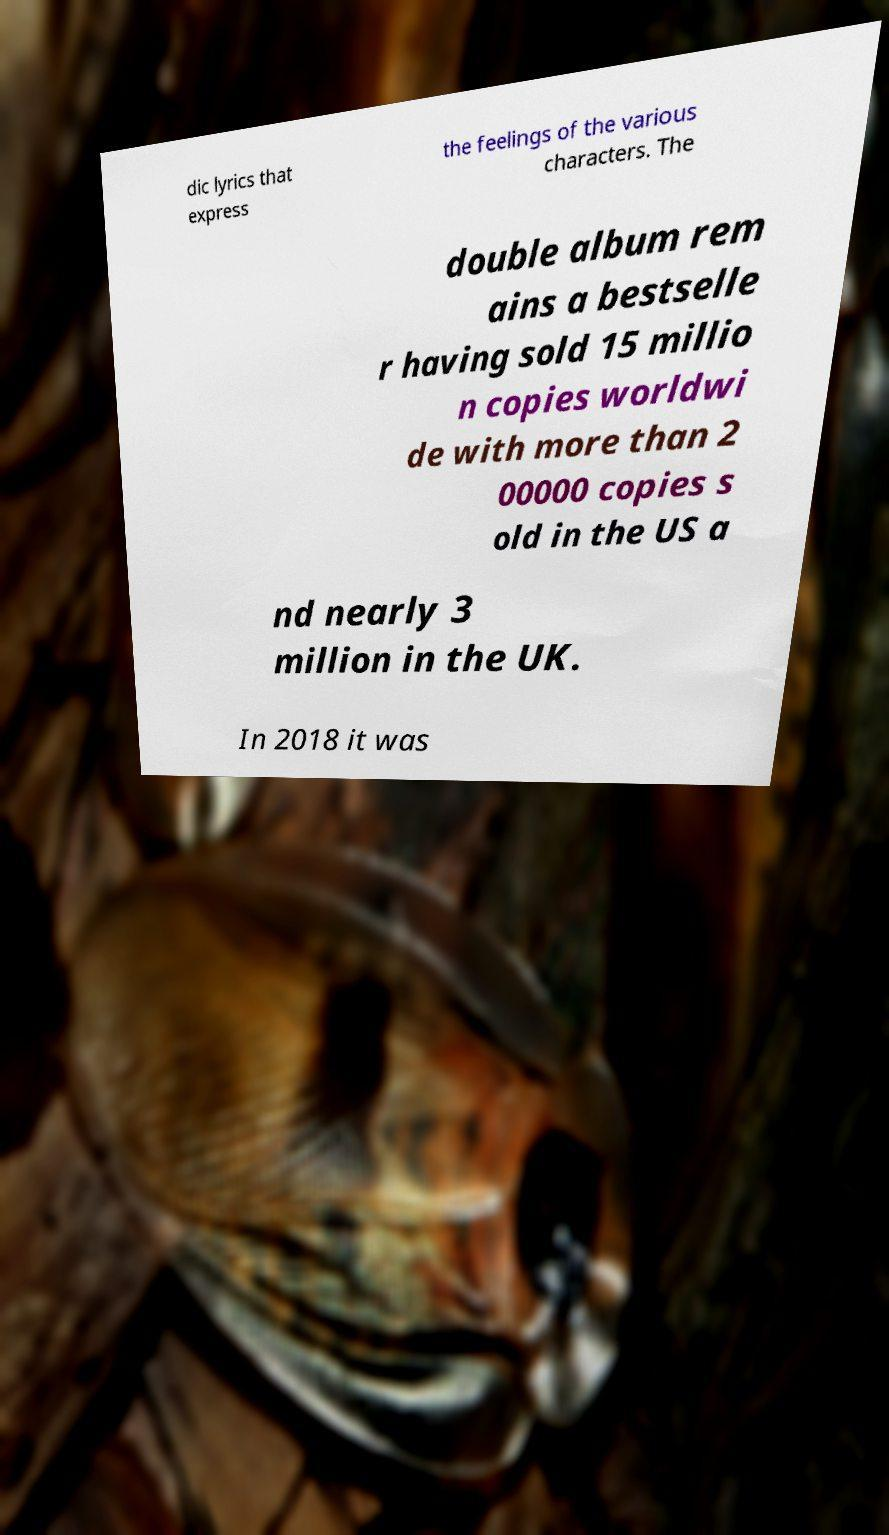Please identify and transcribe the text found in this image. dic lyrics that express the feelings of the various characters. The double album rem ains a bestselle r having sold 15 millio n copies worldwi de with more than 2 00000 copies s old in the US a nd nearly 3 million in the UK. In 2018 it was 